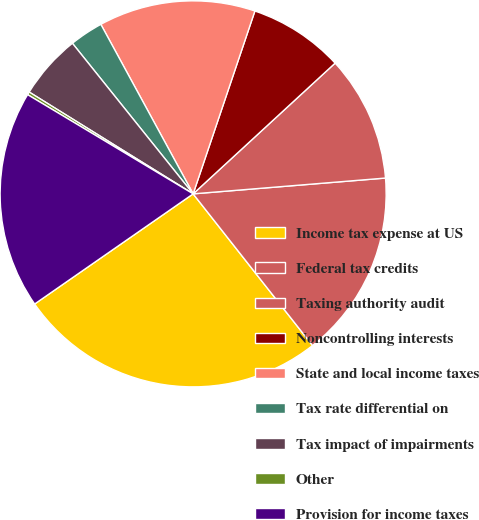Convert chart. <chart><loc_0><loc_0><loc_500><loc_500><pie_chart><fcel>Income tax expense at US<fcel>Federal tax credits<fcel>Taxing authority audit<fcel>Noncontrolling interests<fcel>State and local income taxes<fcel>Tax rate differential on<fcel>Tax impact of impairments<fcel>Other<fcel>Provision for income taxes<nl><fcel>25.95%<fcel>15.69%<fcel>10.54%<fcel>7.97%<fcel>13.12%<fcel>2.82%<fcel>5.4%<fcel>0.25%<fcel>18.26%<nl></chart> 